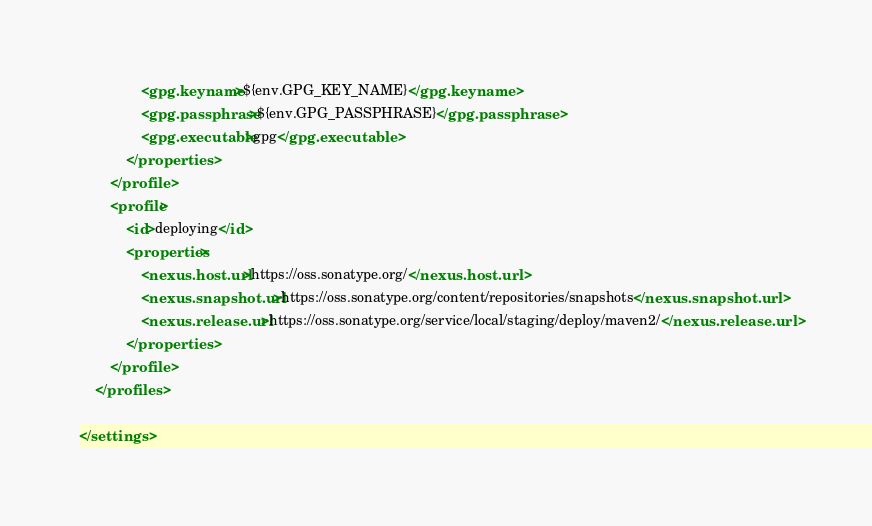<code> <loc_0><loc_0><loc_500><loc_500><_XML_>                <gpg.keyname>${env.GPG_KEY_NAME}</gpg.keyname>
                <gpg.passphrase>${env.GPG_PASSPHRASE}</gpg.passphrase>
                <gpg.executable>gpg</gpg.executable>
            </properties>
        </profile>
        <profile>
            <id>deploying</id>
            <properties>
                <nexus.host.url>https://oss.sonatype.org/</nexus.host.url>
                <nexus.snapshot.url>https://oss.sonatype.org/content/repositories/snapshots</nexus.snapshot.url>
                <nexus.release.url>https://oss.sonatype.org/service/local/staging/deploy/maven2/</nexus.release.url>
            </properties>
        </profile>
    </profiles>

</settings>
</code> 